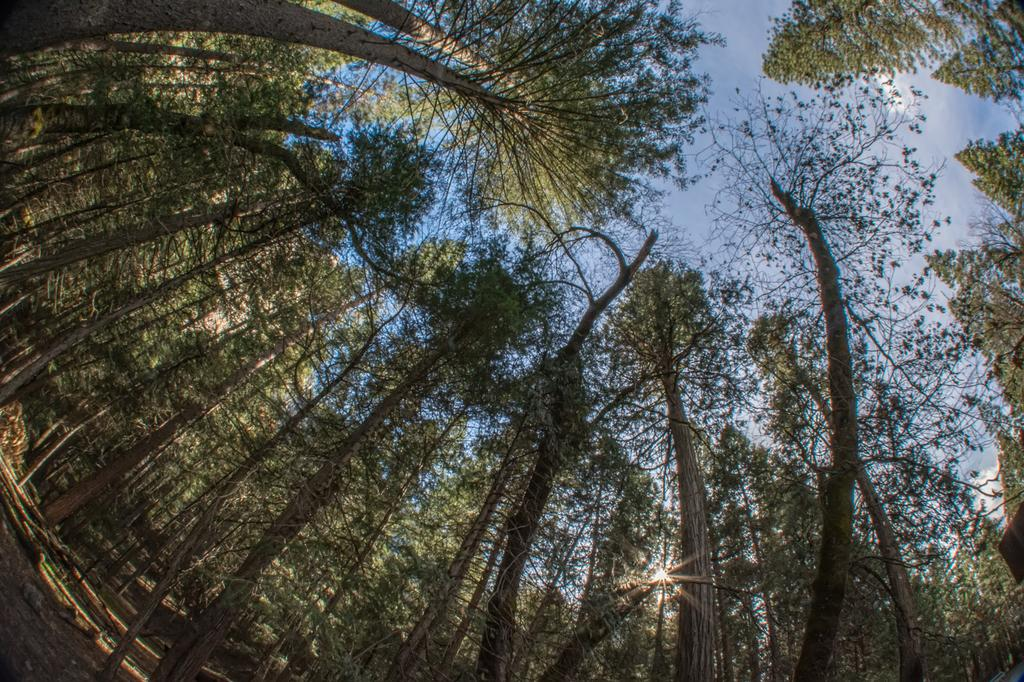What type of vegetation can be seen in the image? There are trees in the image. What can be seen in the sky in the image? There are clouds in the sky. Where is the dad sitting in the image? There is no dad present in the image; it only features trees and clouds. How many ladybugs can be seen on the trees in the image? There are no ladybugs visible in the image; it only features trees and clouds. 